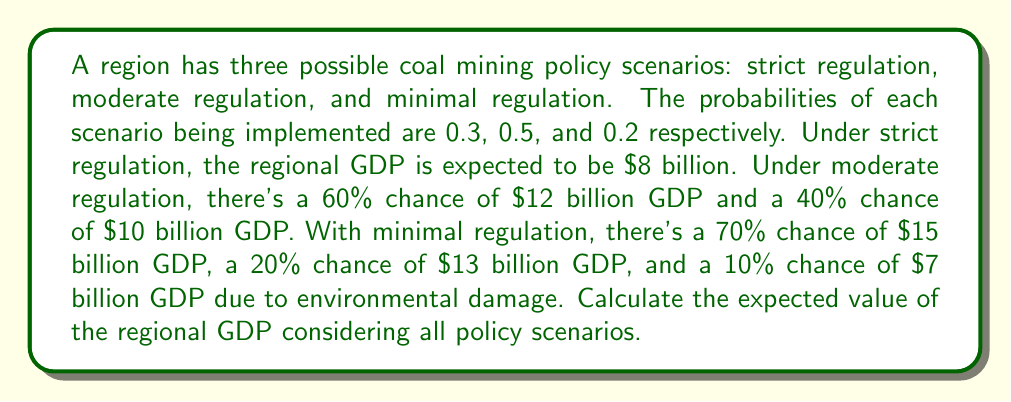Give your solution to this math problem. Let's approach this step-by-step:

1) First, let's calculate the expected GDP for each scenario:

   a) Strict regulation: 
      $E(\text{Strict}) = $8 billion (given)

   b) Moderate regulation:
      $E(\text{Moderate}) = 0.6 \times $12 billion + 0.4 \times $10 billion
                          = $7.2 billion + $4 billion
                          = $11 billion

   c) Minimal regulation:
      $E(\text{Minimal}) = 0.7 \times $15 billion + 0.2 \times $13 billion + 0.1 \times $7 billion
                         = $10.5 billion + $2.6 billion + $0.7 billion
                         = $13.8 billion

2) Now, we can calculate the overall expected value using the law of total expectation:

   $E(\text{GDP}) = P(\text{Strict}) \times E(\text{Strict}) + P(\text{Moderate}) \times E(\text{Moderate}) + P(\text{Minimal}) \times E(\text{Minimal})$

   $E(\text{GDP}) = 0.3 \times $8 billion + 0.5 \times $11 billion + 0.2 \times $13.8 billion$

3) Let's compute this:
   
   $E(\text{GDP}) = $2.4 billion + $5.5 billion + $2.76 billion
                  = $10.66 billion$

Therefore, the expected value of the regional GDP considering all policy scenarios is $10.66 billion.
Answer: $10.66 billion 